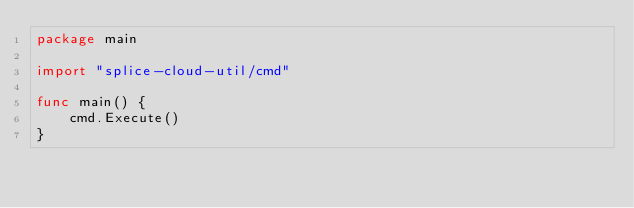<code> <loc_0><loc_0><loc_500><loc_500><_Go_>package main

import "splice-cloud-util/cmd"

func main() {
	cmd.Execute()
}
</code> 